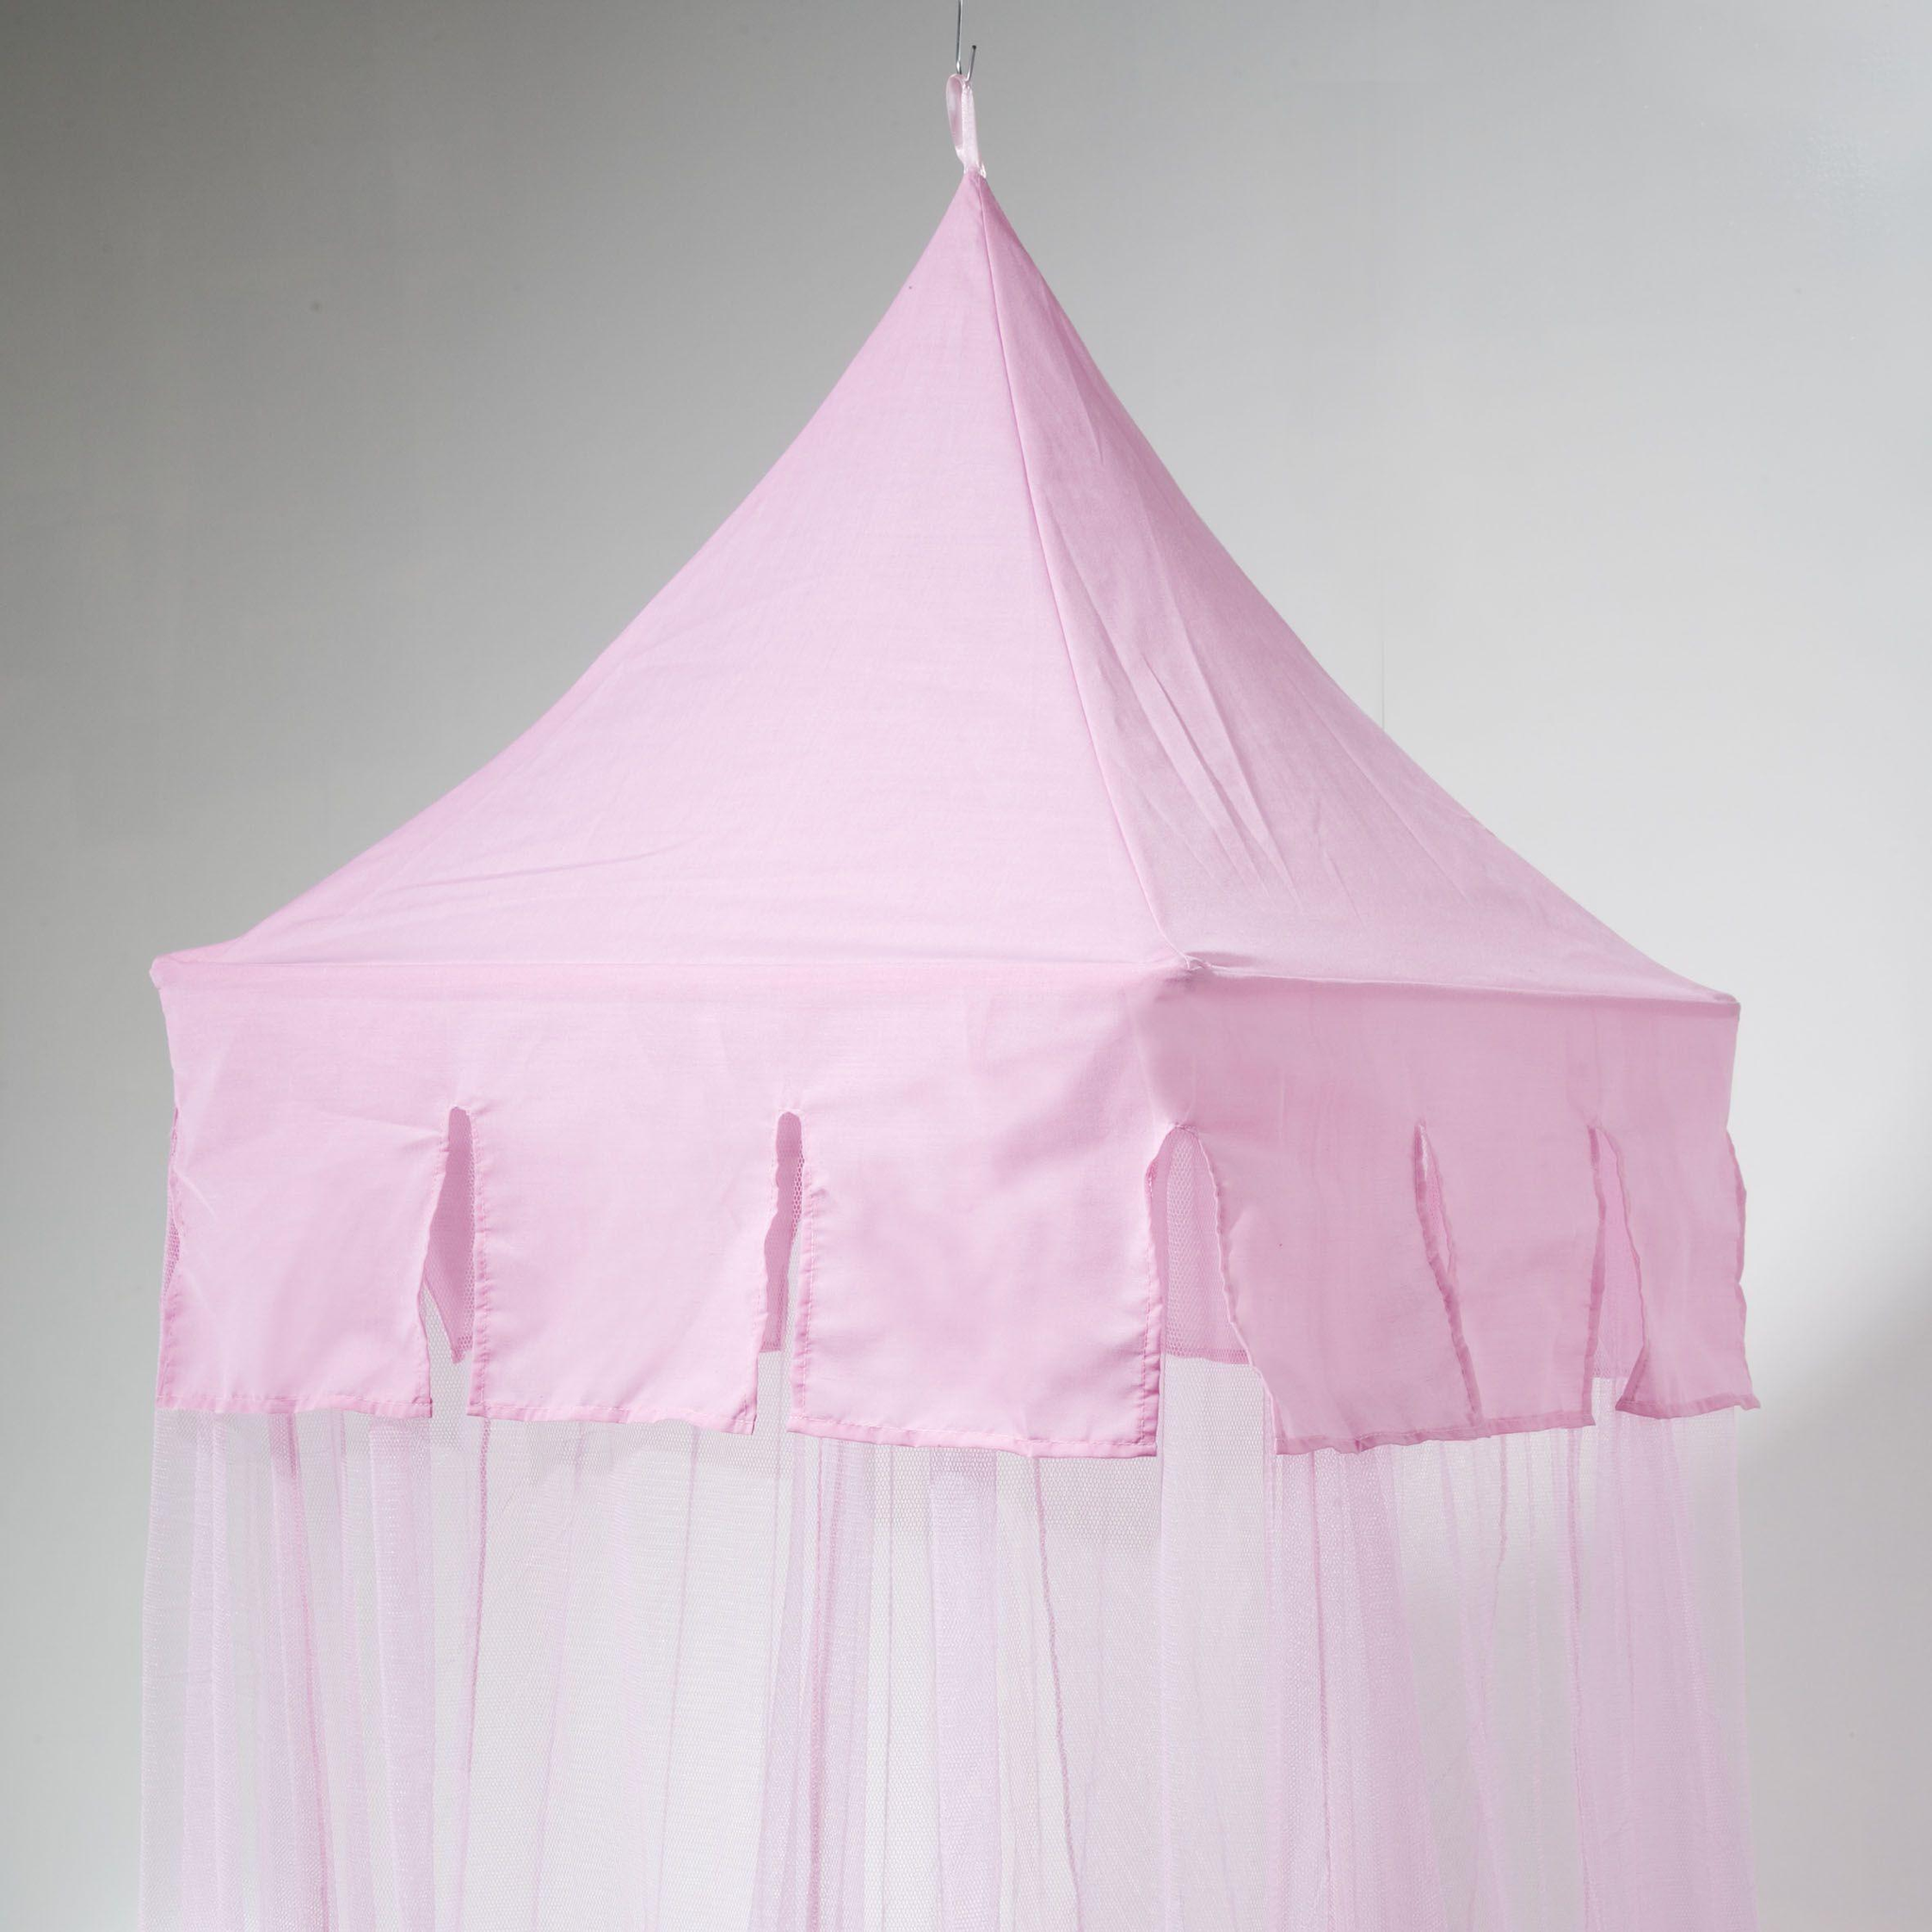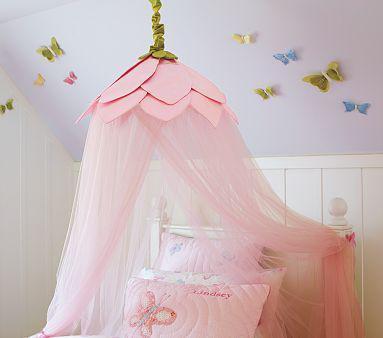The first image is the image on the left, the second image is the image on the right. Assess this claim about the two images: "Only two pillows are visible ont he right image.". Correct or not? Answer yes or no. No. 